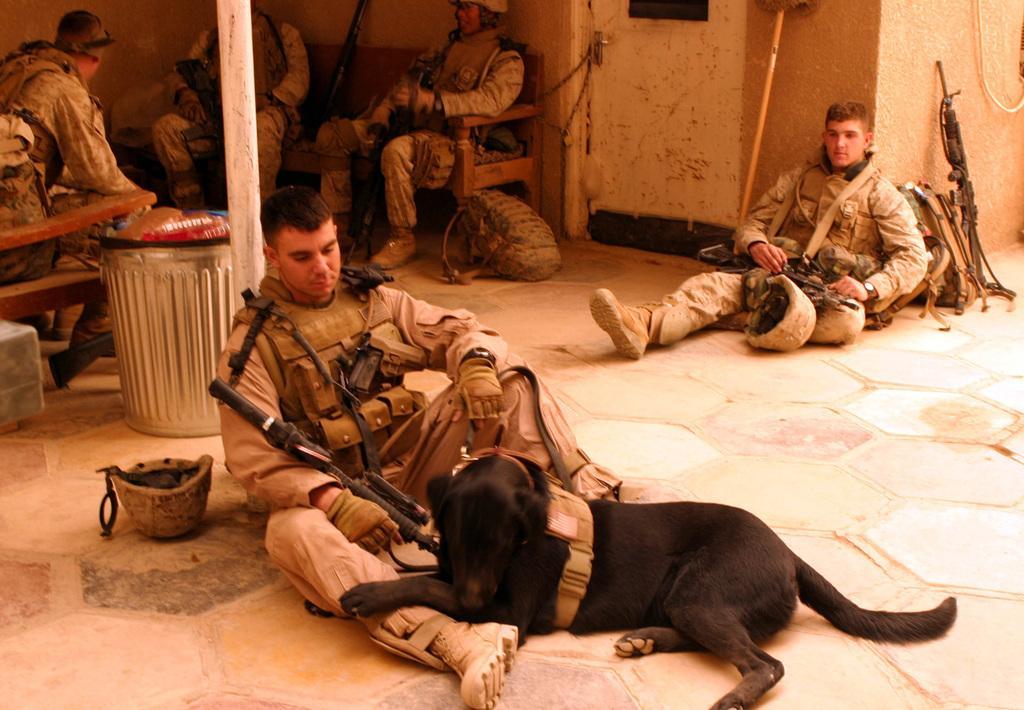Please provide a concise description of this image. In this Image I see 5 men who are sitting on the floor and sofa and they have guns near to them and there is a dog over here and I also see there is a door and the wall over here. 